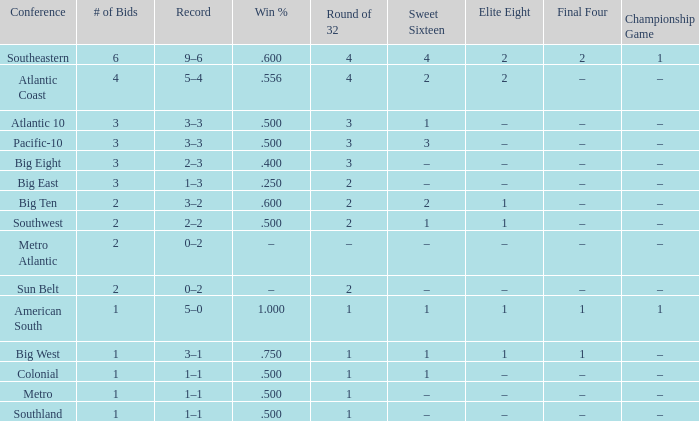What Sweet Sixteen team is in the Colonial conference? 1.0. 